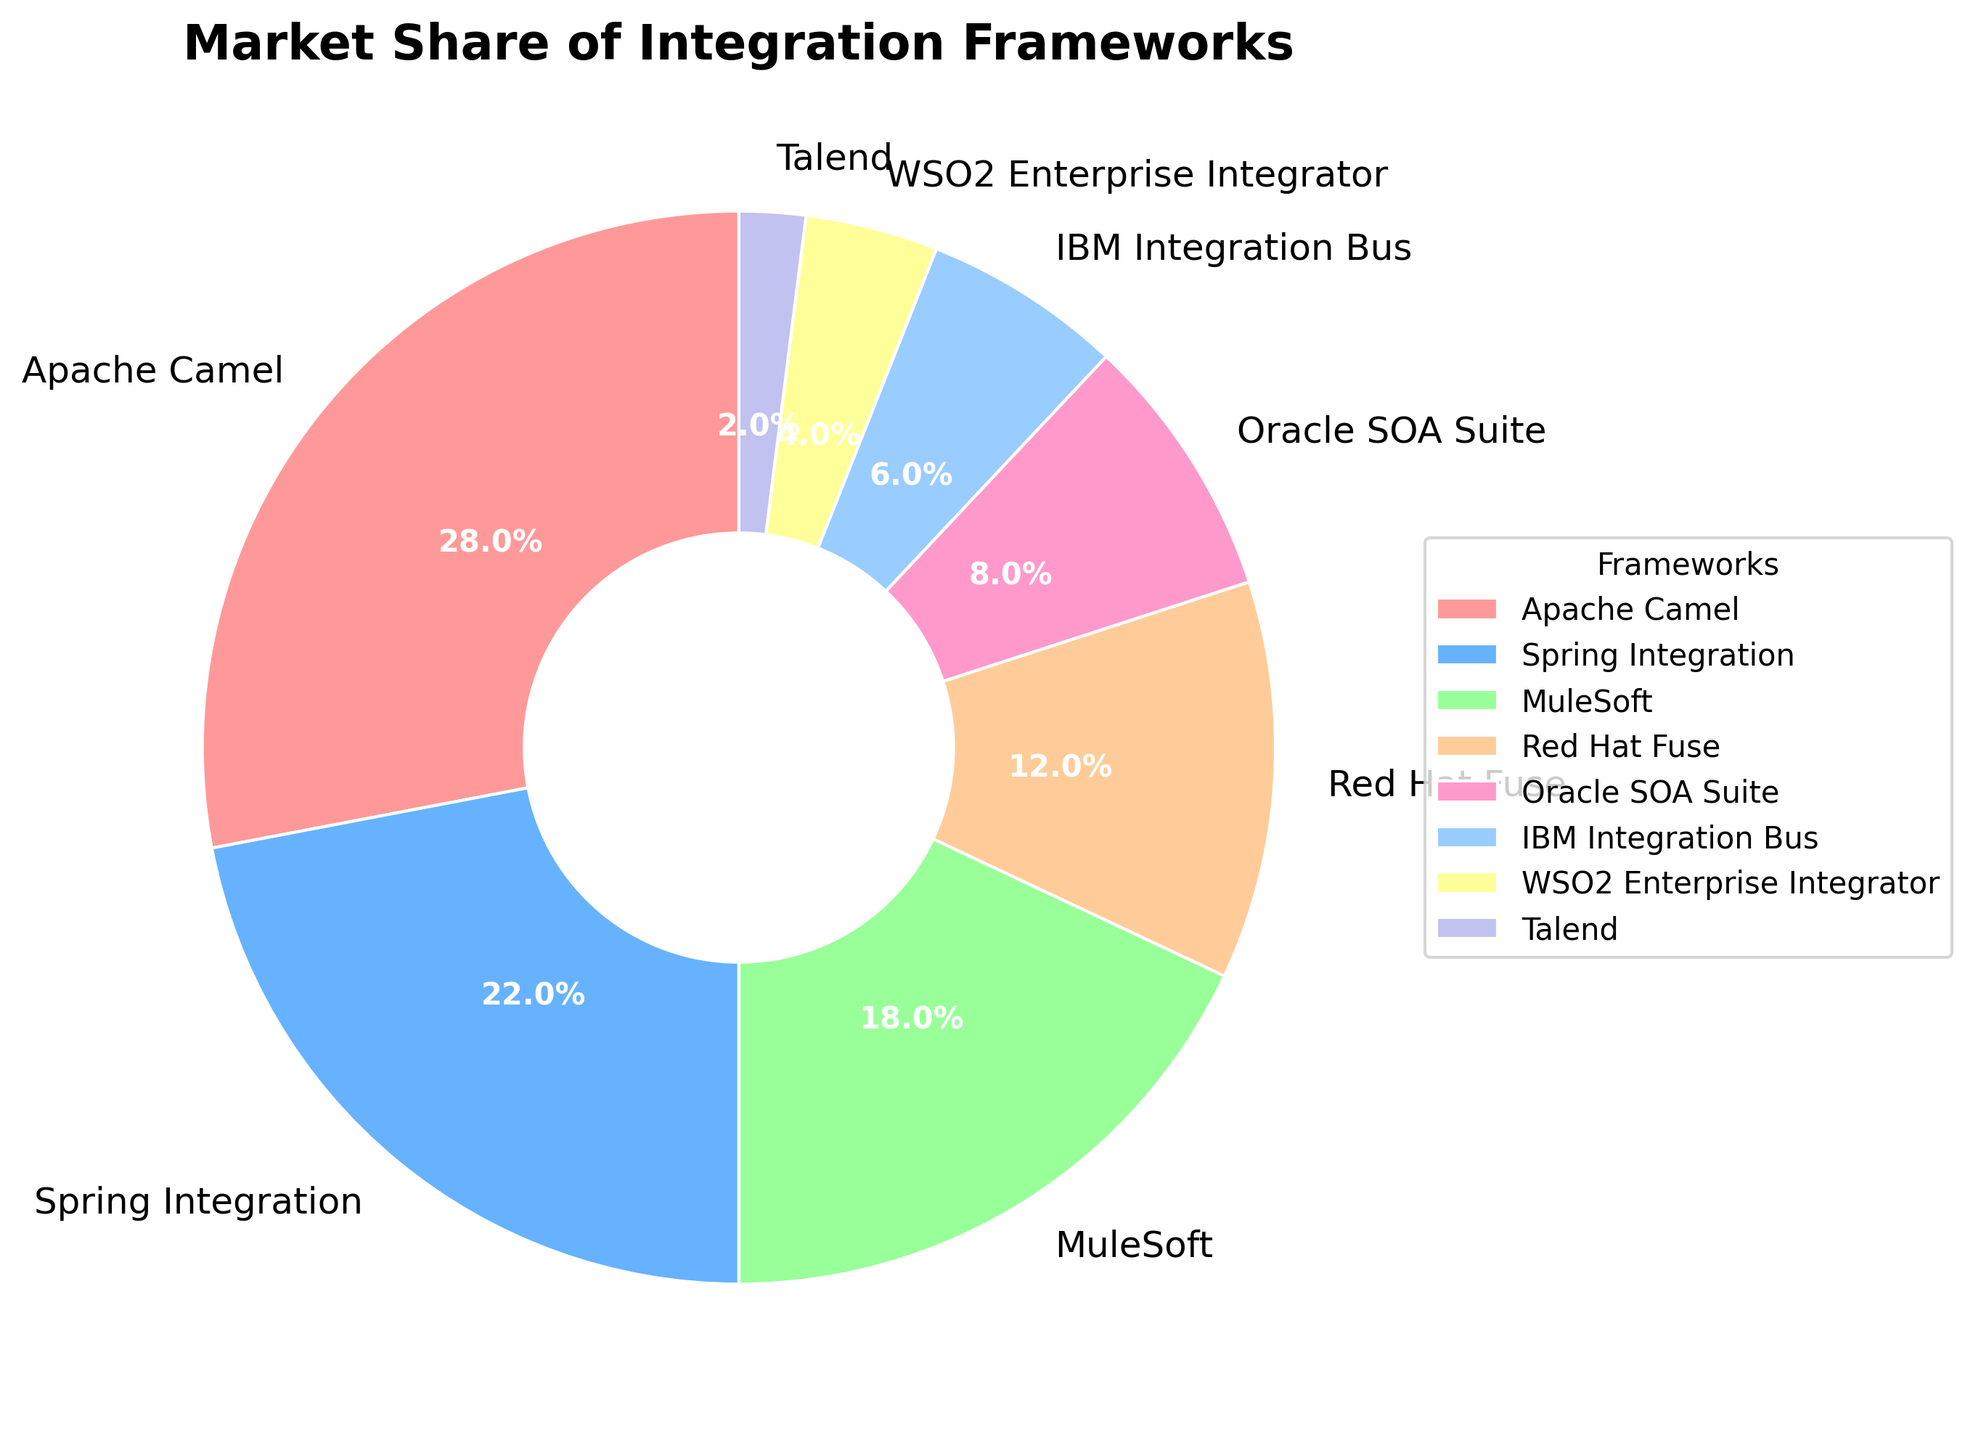What's the market share percentage of Apache Camel? The slice labeled "Apache Camel" shows a market share. From the chart, it is clear that the value is 28%.
Answer: 28% Which two frameworks have the smallest market share, and what are their combined market shares? The smallest market shares are indicated by the smallest slices. Talend has 2% and WSO2 Enterprise Integrator has 4%. Combined, they sum to 2% + 4% = 6%.
Answer: Talend and WSO2 Enterprise Integrator, 6% How does the market share of Spring Integration compare to MuleSoft? Compare the slices labeled "Spring Integration" and "MuleSoft." Spring Integration has 22%, while MuleSoft has 18%. 22% is greater than 18%.
Answer: Spring Integration has a higher market share What is the difference in market share between Red Hat Fuse and Oracle SOA Suite? Identify and compare the slices for Red Hat Fuse and Oracle SOA Suite. Red Hat Fuse has 12% and Oracle SOA Suite has 8%. The difference is 12% - 8% = 4%.
Answer: 4% Which framework is displayed with the largest green slice, and what is its share? The green color is paired with specific wedges in the pie chart. The green slice represents "Spring Integration" which has a market share of 22%.
Answer: Spring Integration, 22% What is the combined market share of IBM Integration Bus and WSO2 Enterprise Integrator? Add the market shares of IBM Integration Bus and WSO2 Enterprise Integrator. IBM Integration Bus has 6% and WSO2 Enterprise Integrator has 4%. Combined, they sum to 6% + 4% = 10%.
Answer: 10% Which framework has about one-third the market share of Apache Camel, and what is its market share? One-third of Apache Camel's 28% is approximately 28% / 3 = 9.33%. Oracle SOA Suite is the closest with 8%, which is roughly one-third of Apache Camel's market share.
Answer: Oracle SOA Suite, 8% What percentage of the market is held by the frameworks with market shares less than 10%? Identify the frameworks with market shares less than 10% (Oracle SOA Suite, IBM Integration Bus, WSO2 Enterprise Integrator, and Talend). Sum these shares: 8% + 6% + 4% + 2% = 20%.
Answer: 20% What fraction of the market share does Red Hat Fuse hold compared to Apache Camel? Compare the market shares of Red Hat Fuse (12%) and Apache Camel (28%). The fraction is 12% / 28% = 0.4286, which can be approximated by multiplying both numerator and denominator by 100, giving approx 43%.
Answer: Approx. 43% Which framework has the highest market share, and how is this depicted in the chart? The largest slice represents the highest market share; from the pie chart, "Apache Camel" has the largest slice and a market share of 28%.
Answer: Apache Camel, depicted by the largest slice 